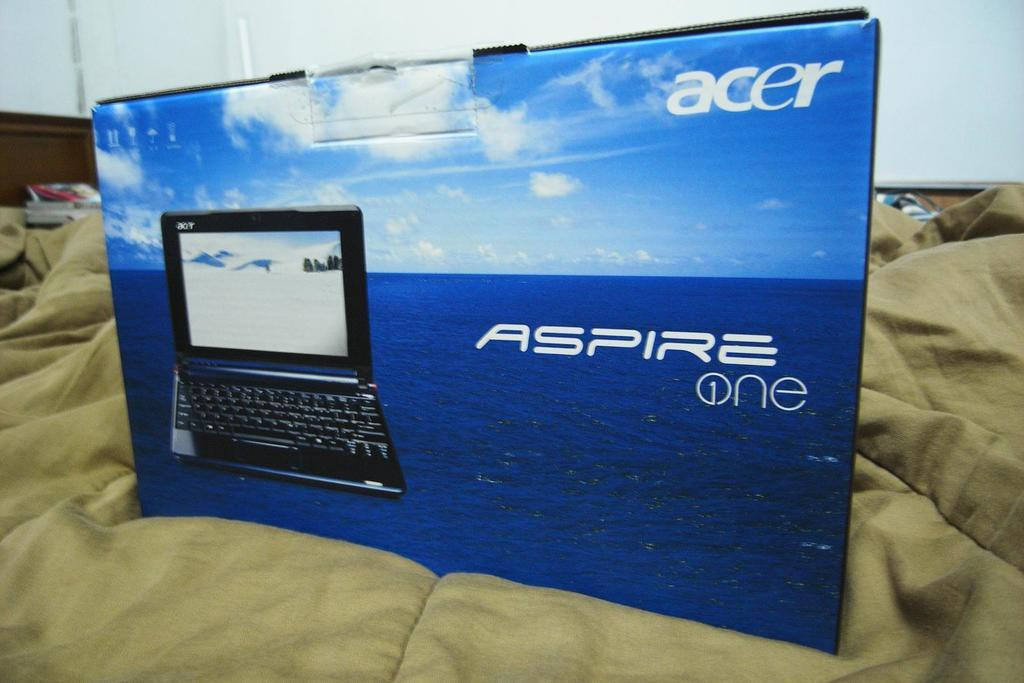<image>
Offer a succinct explanation of the picture presented. The packaging for an Acer branded laptop is on top of the bed. 